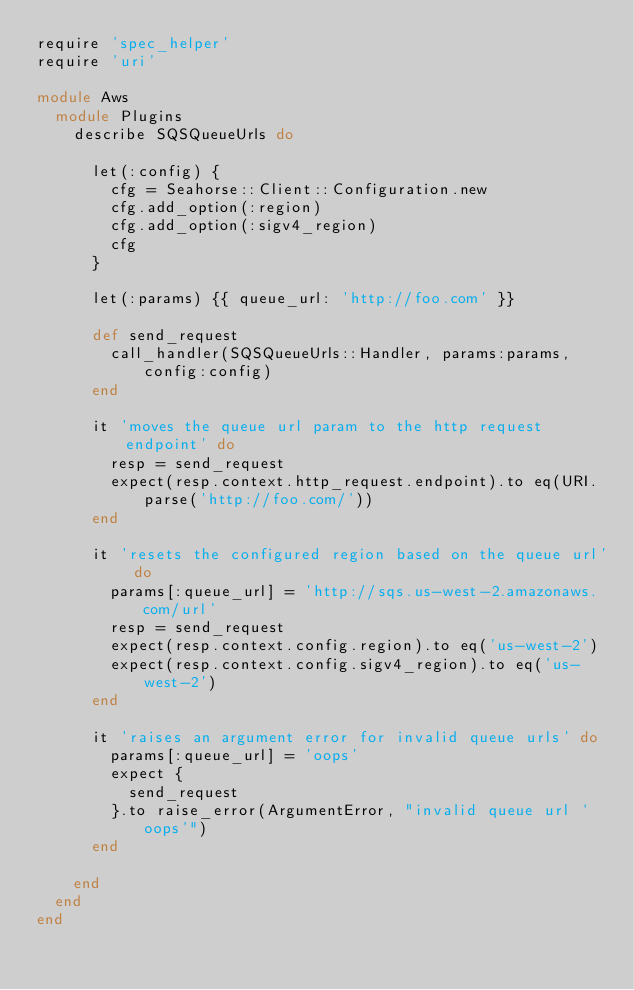<code> <loc_0><loc_0><loc_500><loc_500><_Ruby_>require 'spec_helper'
require 'uri'

module Aws
  module Plugins
    describe SQSQueueUrls do

      let(:config) {
        cfg = Seahorse::Client::Configuration.new
        cfg.add_option(:region)
        cfg.add_option(:sigv4_region)
        cfg
      }

      let(:params) {{ queue_url: 'http://foo.com' }}

      def send_request
        call_handler(SQSQueueUrls::Handler, params:params, config:config)
      end

      it 'moves the queue url param to the http request endpoint' do
        resp = send_request
        expect(resp.context.http_request.endpoint).to eq(URI.parse('http://foo.com/'))
      end

      it 'resets the configured region based on the queue url' do
        params[:queue_url] = 'http://sqs.us-west-2.amazonaws.com/url'
        resp = send_request
        expect(resp.context.config.region).to eq('us-west-2')
        expect(resp.context.config.sigv4_region).to eq('us-west-2')
      end

      it 'raises an argument error for invalid queue urls' do
        params[:queue_url] = 'oops'
        expect {
          send_request
        }.to raise_error(ArgumentError, "invalid queue url `oops'")
      end

    end
  end
end
</code> 